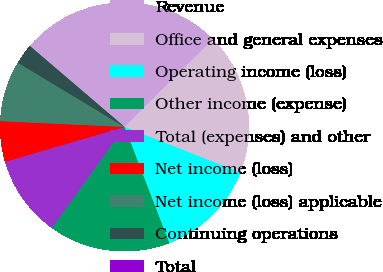Convert chart. <chart><loc_0><loc_0><loc_500><loc_500><pie_chart><fcel>Revenue<fcel>Office and general expenses<fcel>Operating income (loss)<fcel>Other income (expense)<fcel>Total (expenses) and other<fcel>Net income (loss)<fcel>Net income (loss) applicable<fcel>Continuing operations<fcel>Total<nl><fcel>26.32%<fcel>18.42%<fcel>13.16%<fcel>15.79%<fcel>10.53%<fcel>5.26%<fcel>7.89%<fcel>2.63%<fcel>0.0%<nl></chart> 